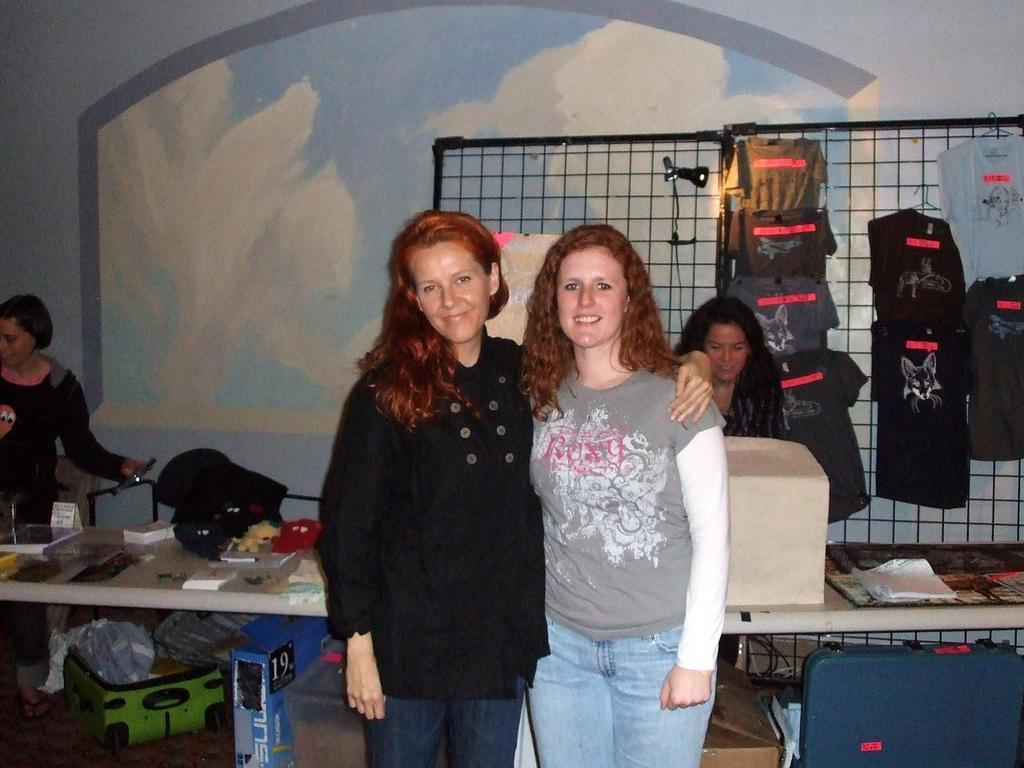How many people are in the image? There are two women in the image. What are the women doing in the image? The women are posing for the camera. What can be seen hanging on the wall in the image? There are T-shirts hanging on a grilled wall. What is visible on a surface in the background of the image? There are articles on a table in the background. What type of sticks are being used by the women in the image? There are no sticks visible in the image; the women are posing for the camera without any sticks. How many feet can be seen in the image? The number of feet visible in the image cannot be determined from the provided facts, as the focus is on the women posing for the camera and not their feet. 